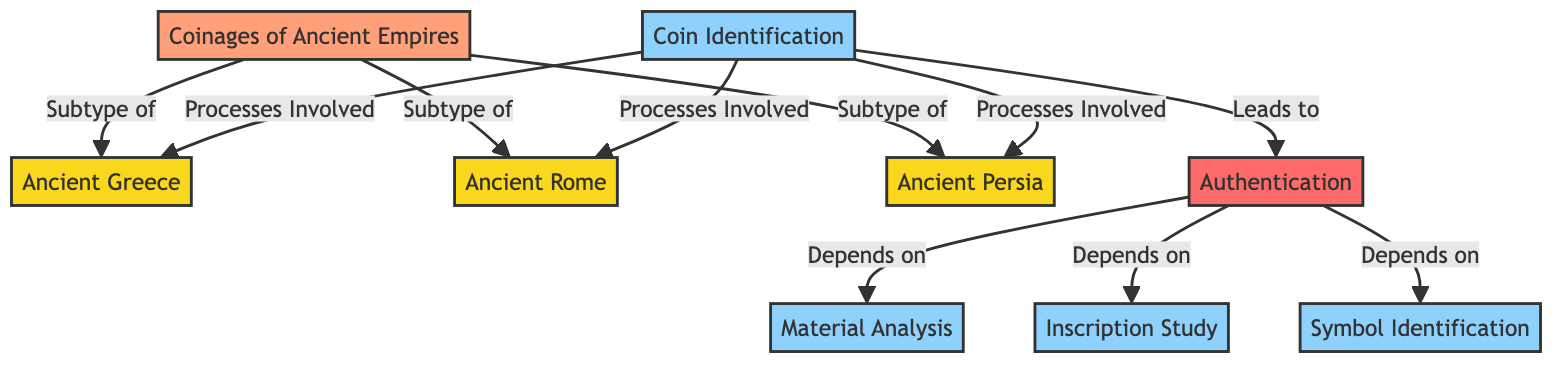What are the three ancient empires depicted in this diagram? The diagram lists three ancient empires: Ancient Greece, Ancient Rome, and Ancient Persia as subtypes of Coinages of Ancient Empires.
Answer: Ancient Greece, Ancient Rome, Ancient Persia How many processes are involved in coin identification? The diagram shows four processes involved in coin identification: Material Analysis, Inscription Study, and Symbol Identification, which are directly connected to Coin Identification.
Answer: Four Which process leads to authentication? The diagram indicates that the Coin Identification process leads to Authentication as the next step in the flow.
Answer: Coin Identification What does authentication depend on? Authentication depends on three processes: Material Analysis, Inscription Study, and Symbol Identification, as shown by the connections in the diagram.
Answer: Material Analysis, Inscription Study, Symbol Identification What is the color used to represent the ancient empires in the diagram? The class definition for the ancient empires shows that they are represented with a fill color of yellow (#f9d71c) in the diagram.
Answer: Yellow 